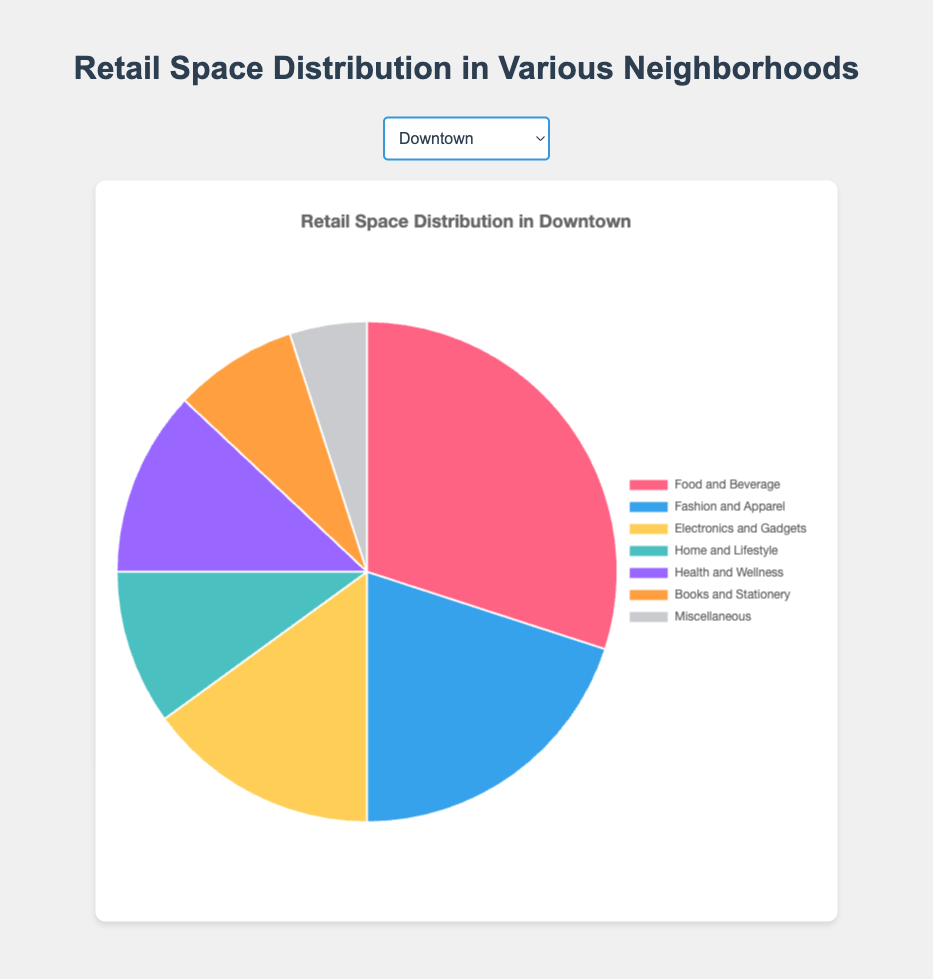What is the neighborhood with the highest percentage allocated to Food and Beverage? The neighborhoods each have a different breakdown of retail space categories. By looking at the pie charts for each neighborhood, you'll see that Old Town has the largest portion (40%) designated to Food and Beverage, which is the highest among all neighborhoods.
Answer: Old Town Which two neighborhoods allocate an equal percentage of retail space to Fashion and Apparel? Comparing the percentages for Fashion and Apparel across all neighborhoods, you find that Suburbia Heights and Old Town both allocate 15% of their retail space to this category.
Answer: Suburbia Heights, Old Town What is the sum of the percentages for Health and Wellness and Electronics and Gadgets in Uptown? For Uptown, Health and Wellness is 10%, and Electronics and Gadgets is 20%. Adding these two percentages together gives you 10% + 20% = 30%.
Answer: 30% Which neighborhood has the smallest percentage devoted to Books and Stationery? By examining the pie charts for each neighborhood, you'll see that Downtown, Midtown, Uptown, and Old Town all have the smallest percentage devoted to Books and Stationery at 5%. Comparing these, Suburbia Heights stands out with a slightly larger percentage at 7%. Therefore, the neighborhoods with the smallest percentage (5%) for Books and Stationery are Downtown, Midtown, Uptown, and Old Town.
Answer: Downtown, Midtown, Uptown, Old Town How does the percentage of Home and Lifestyle in Midtown compare to Suburbia Heights? Midtown allocates 10% of its retail space to Home and Lifestyle, while Suburbia Heights allocates 20%. This shows that Suburbia Heights allocates double the percentage of retail space for Home and Lifestyle compared to Midtown.
Answer: Suburbia Heights has higher What is the average percentage allocation for Health and Wellness across all neighborhoods? Adding the percentages for Health and Wellness from each neighborhood (12% (Downtown) + 18% (Suburbia Heights) + 10% (Midtown) + 10% (Uptown) + 10% (Old Town)), we get a total of 60%. Dividing by the 5 neighborhoods gives the average: 60% / 5 = 12%.
Answer: 12% If you sum the percentages of Food and Beverage and Miscellaneous in Midtown, how does it compare to Food and Beverage alone in Downtown? In Midtown, Food and Beverage is 35% and Miscellaneous is 5%, which sums to 40%. In Downtown, Food and Beverage alone is 30%. Therefore, 40% (Midtown) is greater than 30% (Downtown).
Answer: Greater What is the difference in the percentage allocation for Electronics and Gadgets between Downtown and Uptown? Downtown has 15% allocated to Electronics and Gadgets, while Uptown has 20%. The difference is calculated by 20% - 15% = 5%.
Answer: 5% Which retail category has the least variation in percentage allocation across all neighborhoods? To determine the least variation, observe the percentages of each category in all neighborhoods. Miscellaneous remains consistently at 5% across all neighborhoods, suggesting the least variation.
Answer: Miscellaneous In which neighborhood do Fashion and Apparel and Food and Beverage have the same percentage allocation? Reviewing each neighborhood's data, you find that in Uptown, Fashion and Apparel and Food and Beverage both have a 20% allocation.
Answer: Uptown 